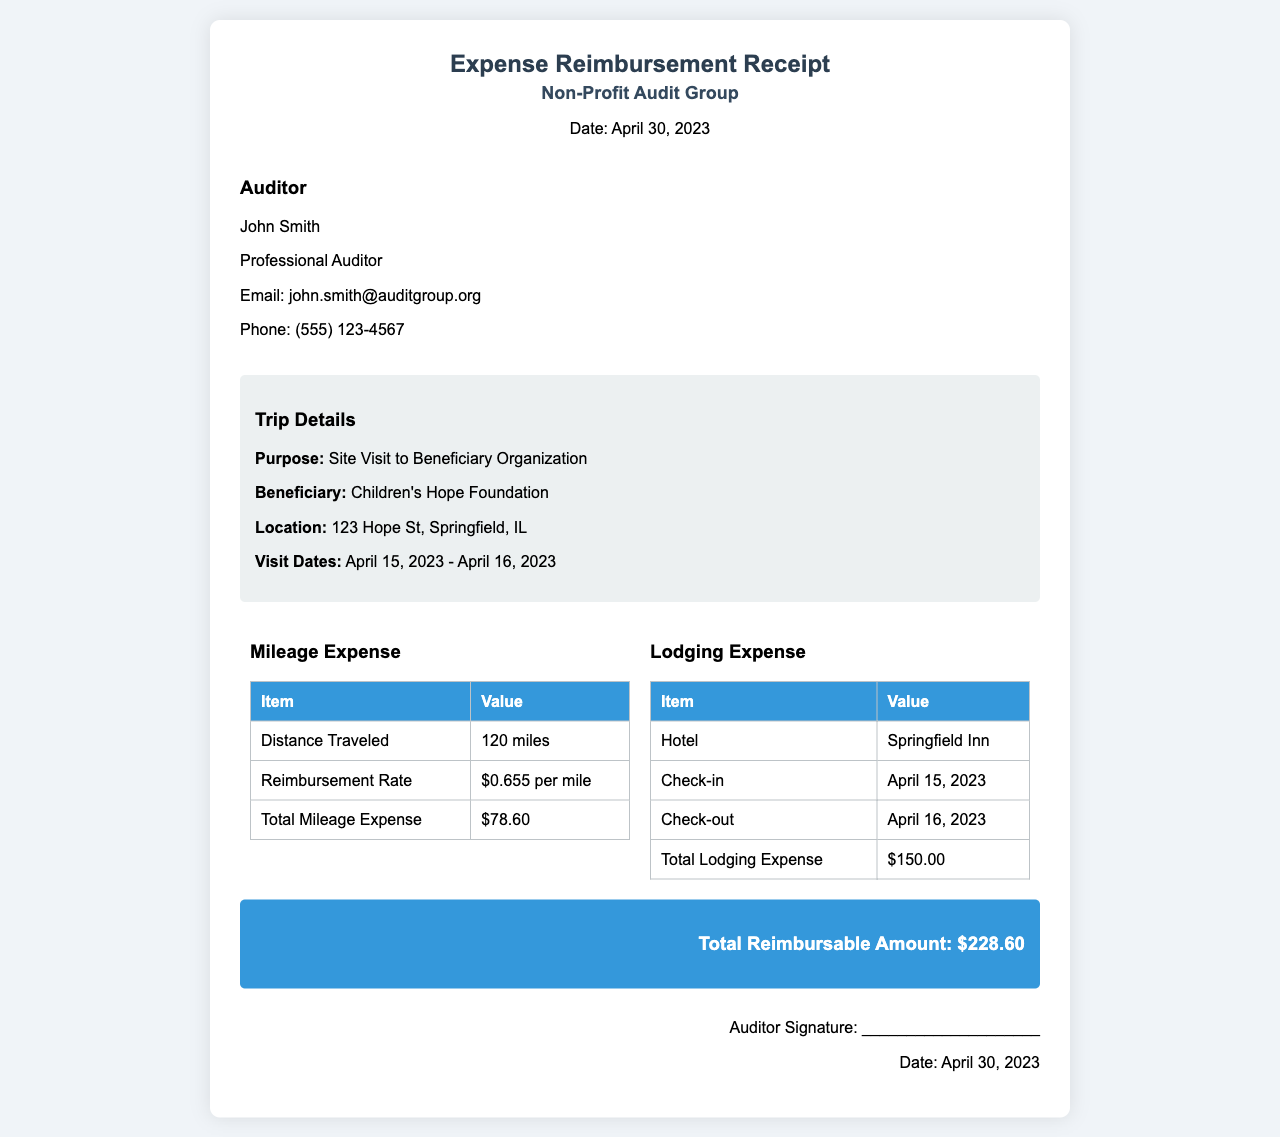What is the purpose of the trip? The document states the purpose as "Site Visit to Beneficiary Organization."
Answer: Site Visit to Beneficiary Organization Who is the auditor? The name of the auditor is provided in the document as "John Smith."
Answer: John Smith What is the total mileage expense? The document specifies the total mileage expense as "$78.60."
Answer: $78.60 When did the site visit occur? The visit dates listed are "April 15, 2023 - April 16, 2023."
Answer: April 15, 2023 - April 16, 2023 What is the total reimbursable amount? The total reimbursable amount summed up in the document is "$228.60."
Answer: $228.60 What hotel was used for lodging? The hotel listed in the document is "Springfield Inn."
Answer: Springfield Inn How many miles were traveled? The distance traveled, according to the document, is "120 miles."
Answer: 120 miles What was the check-out date? The check-out date indicated in the lodging details is "April 16, 2023."
Answer: April 16, 2023 What is the reimbursement rate per mile? The reimbursement rate provided in the document is "$0.655 per mile."
Answer: $0.655 per mile 